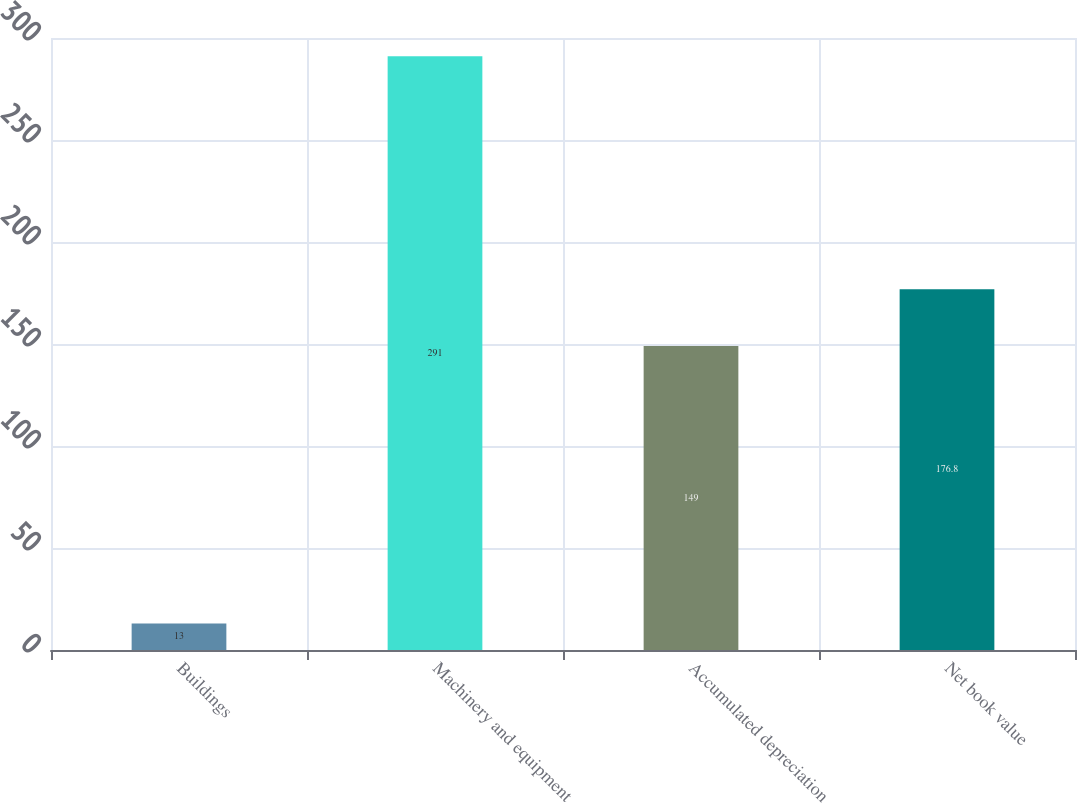Convert chart to OTSL. <chart><loc_0><loc_0><loc_500><loc_500><bar_chart><fcel>Buildings<fcel>Machinery and equipment<fcel>Accumulated depreciation<fcel>Net book value<nl><fcel>13<fcel>291<fcel>149<fcel>176.8<nl></chart> 